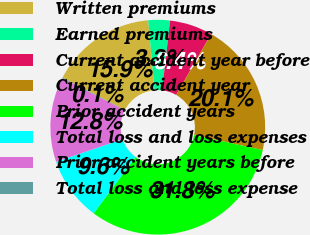Convert chart to OTSL. <chart><loc_0><loc_0><loc_500><loc_500><pie_chart><fcel>Written premiums<fcel>Earned premiums<fcel>Current accident year before<fcel>Current accident year<fcel>Prior accident years<fcel>Total loss and loss expenses<fcel>Prior accident years before<fcel>Total loss and loss expense<nl><fcel>15.94%<fcel>3.26%<fcel>6.43%<fcel>20.14%<fcel>31.78%<fcel>9.6%<fcel>12.77%<fcel>0.09%<nl></chart> 